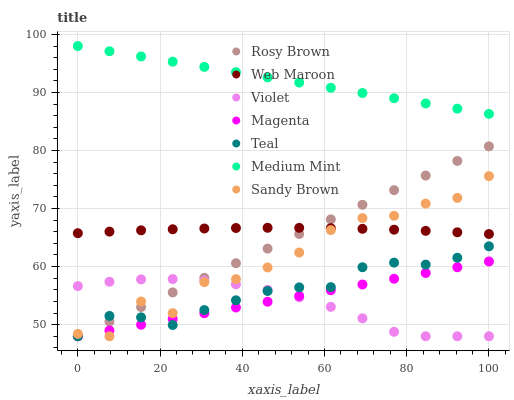Does Violet have the minimum area under the curve?
Answer yes or no. Yes. Does Medium Mint have the maximum area under the curve?
Answer yes or no. Yes. Does Rosy Brown have the minimum area under the curve?
Answer yes or no. No. Does Rosy Brown have the maximum area under the curve?
Answer yes or no. No. Is Medium Mint the smoothest?
Answer yes or no. Yes. Is Sandy Brown the roughest?
Answer yes or no. Yes. Is Rosy Brown the smoothest?
Answer yes or no. No. Is Rosy Brown the roughest?
Answer yes or no. No. Does Rosy Brown have the lowest value?
Answer yes or no. Yes. Does Web Maroon have the lowest value?
Answer yes or no. No. Does Medium Mint have the highest value?
Answer yes or no. Yes. Does Rosy Brown have the highest value?
Answer yes or no. No. Is Rosy Brown less than Medium Mint?
Answer yes or no. Yes. Is Medium Mint greater than Magenta?
Answer yes or no. Yes. Does Web Maroon intersect Rosy Brown?
Answer yes or no. Yes. Is Web Maroon less than Rosy Brown?
Answer yes or no. No. Is Web Maroon greater than Rosy Brown?
Answer yes or no. No. Does Rosy Brown intersect Medium Mint?
Answer yes or no. No. 